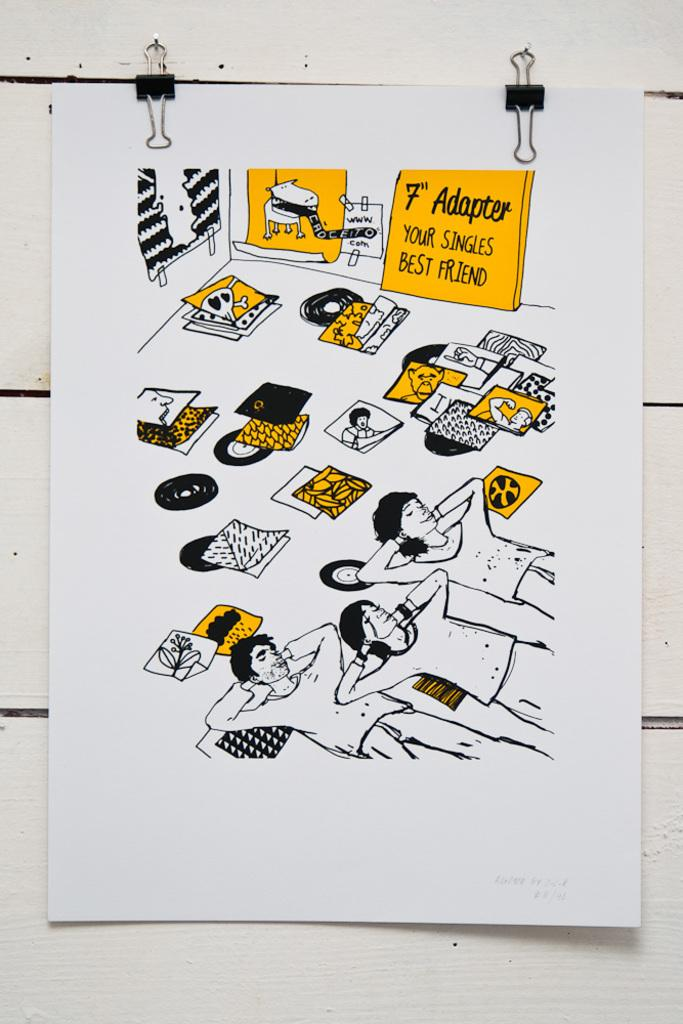<image>
Offer a succinct explanation of the picture presented. A vintage ad for 45 sized single record adapters. 